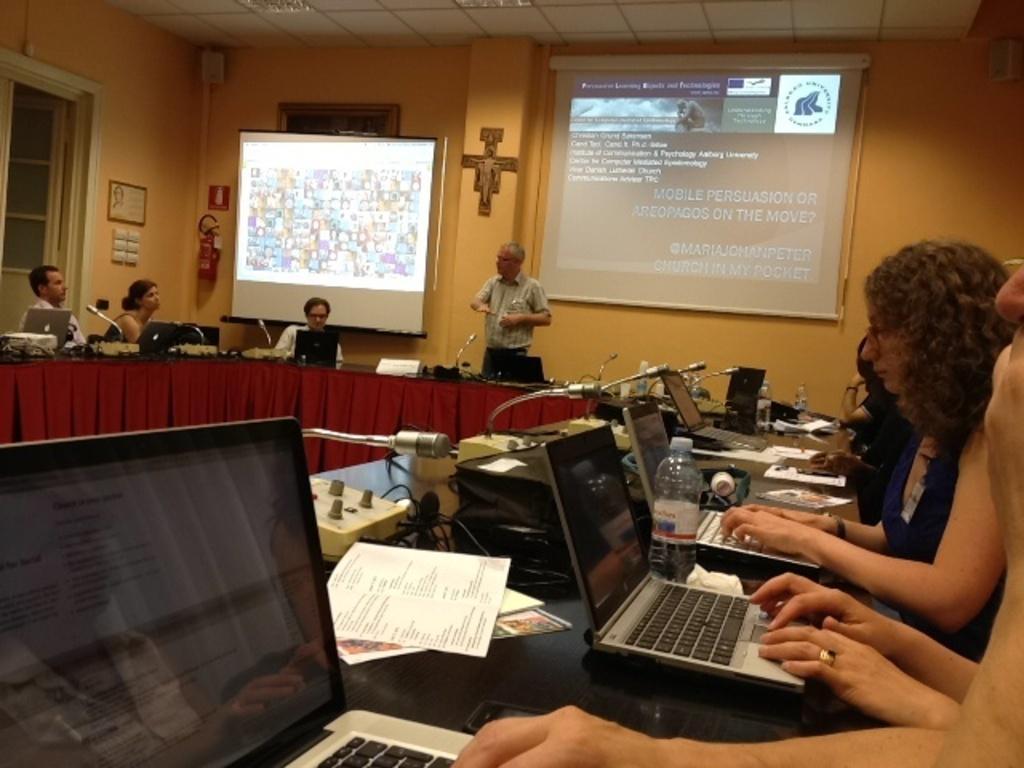Can you describe this image briefly? In this picture I can see group of people sitting on the chairs, there is a man standing, there are laptops, mike's, papers, cables and some other objects on the table, there are frames attached to the wall, there are projector screens, there is a speaker, there is an oxygen cylinder and there are some objects. 